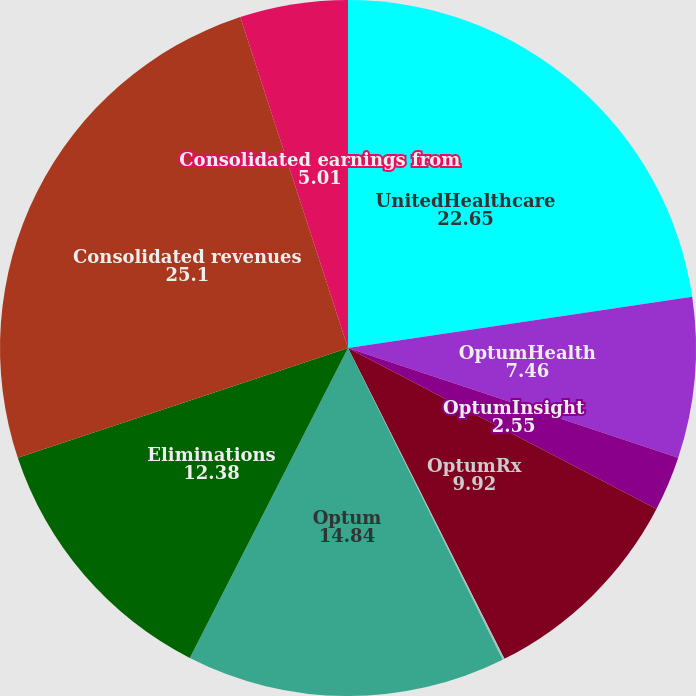<chart> <loc_0><loc_0><loc_500><loc_500><pie_chart><fcel>UnitedHealthcare<fcel>OptumHealth<fcel>OptumInsight<fcel>OptumRx<fcel>Optum eliminations<fcel>Optum<fcel>Eliminations<fcel>Consolidated revenues<fcel>Consolidated earnings from<nl><fcel>22.65%<fcel>7.46%<fcel>2.55%<fcel>9.92%<fcel>0.09%<fcel>14.84%<fcel>12.38%<fcel>25.1%<fcel>5.01%<nl></chart> 